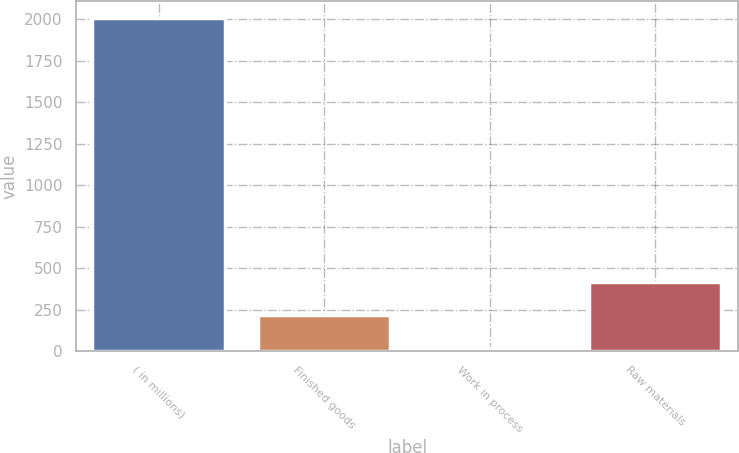<chart> <loc_0><loc_0><loc_500><loc_500><bar_chart><fcel>( in millions)<fcel>Finished goods<fcel>Work in process<fcel>Raw materials<nl><fcel>2009<fcel>218.63<fcel>19.7<fcel>417.56<nl></chart> 